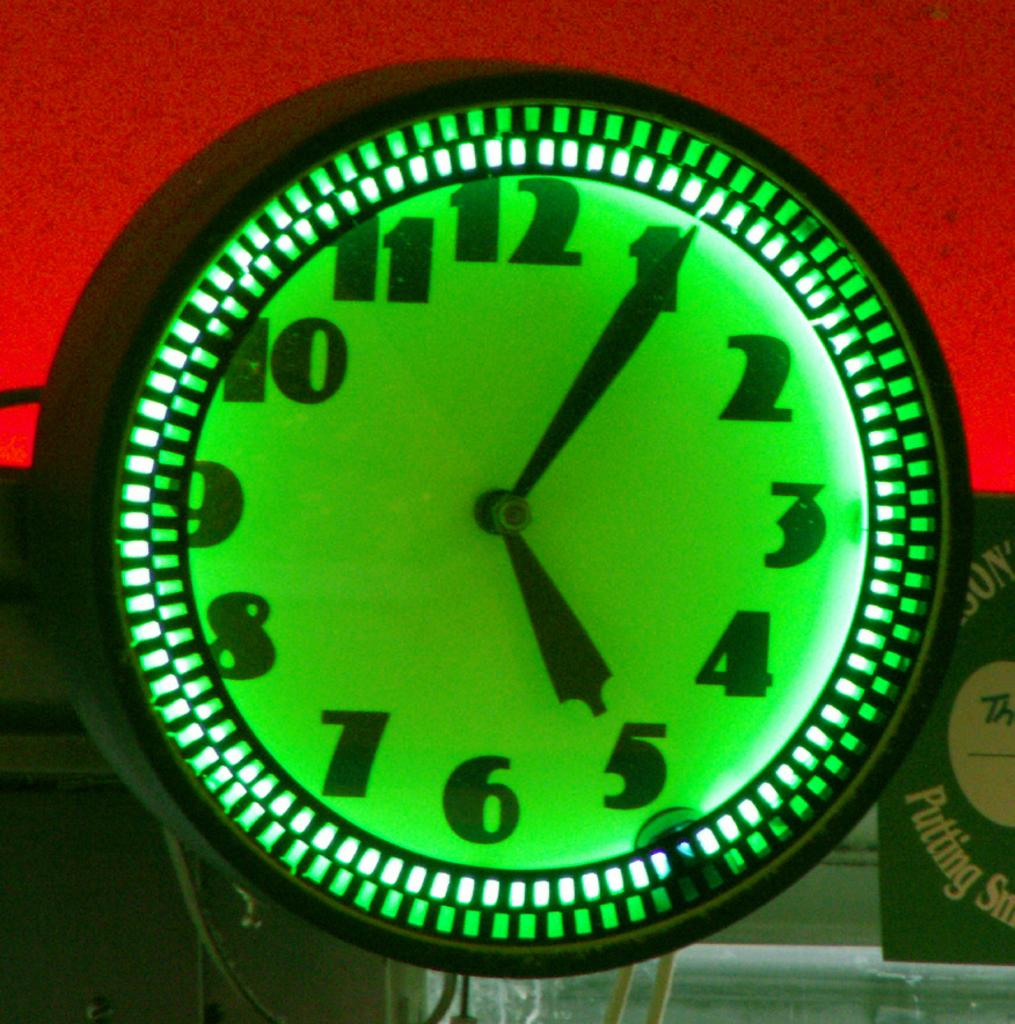<image>
Describe the image concisely. A green neon clock says 5:05 and is next to a sign that says Putting. 